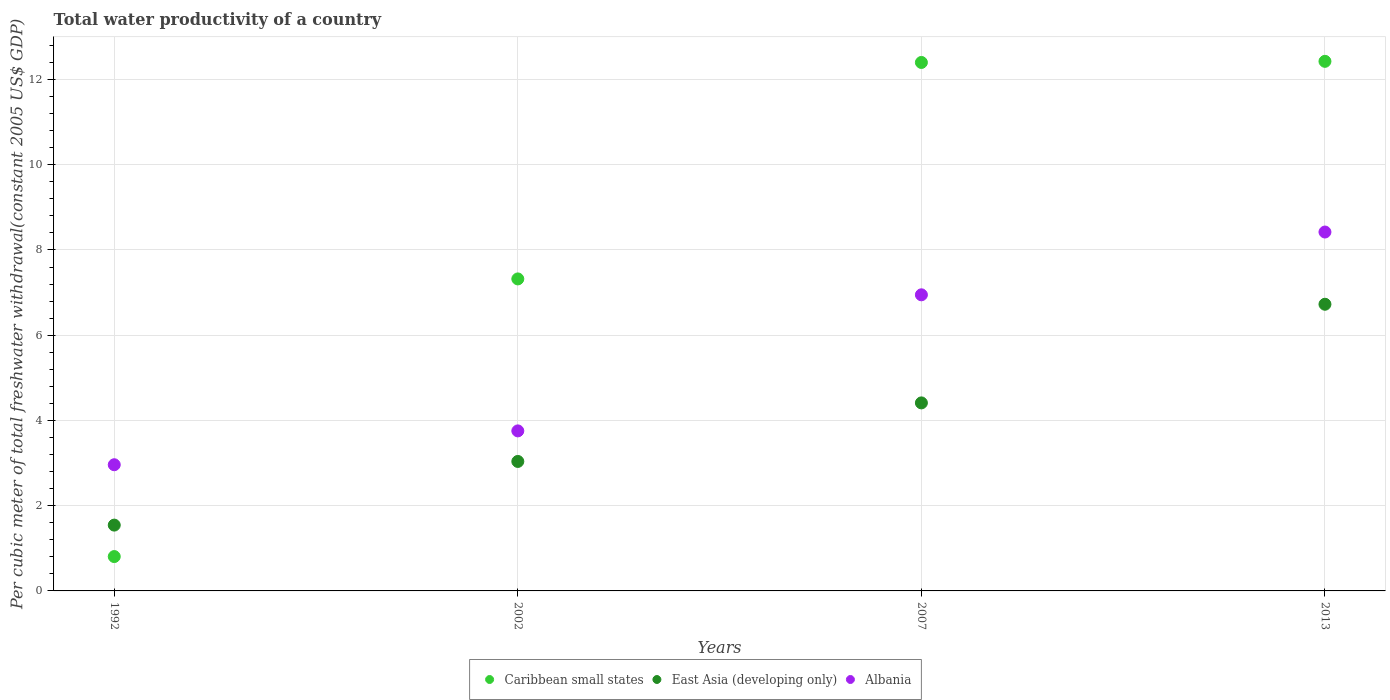How many different coloured dotlines are there?
Your answer should be compact. 3. What is the total water productivity in Albania in 2007?
Ensure brevity in your answer.  6.95. Across all years, what is the maximum total water productivity in Caribbean small states?
Give a very brief answer. 12.43. Across all years, what is the minimum total water productivity in Albania?
Your answer should be compact. 2.96. What is the total total water productivity in Albania in the graph?
Provide a succinct answer. 22.09. What is the difference between the total water productivity in Caribbean small states in 1992 and that in 2013?
Keep it short and to the point. -11.62. What is the difference between the total water productivity in Caribbean small states in 2002 and the total water productivity in Albania in 1992?
Give a very brief answer. 4.36. What is the average total water productivity in East Asia (developing only) per year?
Provide a short and direct response. 3.93. In the year 1992, what is the difference between the total water productivity in Albania and total water productivity in East Asia (developing only)?
Offer a terse response. 1.42. What is the ratio of the total water productivity in Caribbean small states in 1992 to that in 2002?
Provide a succinct answer. 0.11. Is the total water productivity in Albania in 1992 less than that in 2002?
Give a very brief answer. Yes. What is the difference between the highest and the second highest total water productivity in Albania?
Your answer should be compact. 1.47. What is the difference between the highest and the lowest total water productivity in East Asia (developing only)?
Your answer should be very brief. 5.18. Is the total water productivity in Albania strictly greater than the total water productivity in East Asia (developing only) over the years?
Your answer should be compact. Yes. How many years are there in the graph?
Keep it short and to the point. 4. What is the difference between two consecutive major ticks on the Y-axis?
Provide a short and direct response. 2. Does the graph contain grids?
Make the answer very short. Yes. How many legend labels are there?
Keep it short and to the point. 3. How are the legend labels stacked?
Provide a short and direct response. Horizontal. What is the title of the graph?
Ensure brevity in your answer.  Total water productivity of a country. Does "Tunisia" appear as one of the legend labels in the graph?
Give a very brief answer. No. What is the label or title of the X-axis?
Your answer should be compact. Years. What is the label or title of the Y-axis?
Provide a succinct answer. Per cubic meter of total freshwater withdrawal(constant 2005 US$ GDP). What is the Per cubic meter of total freshwater withdrawal(constant 2005 US$ GDP) of Caribbean small states in 1992?
Offer a terse response. 0.81. What is the Per cubic meter of total freshwater withdrawal(constant 2005 US$ GDP) in East Asia (developing only) in 1992?
Provide a succinct answer. 1.54. What is the Per cubic meter of total freshwater withdrawal(constant 2005 US$ GDP) in Albania in 1992?
Offer a very short reply. 2.96. What is the Per cubic meter of total freshwater withdrawal(constant 2005 US$ GDP) in Caribbean small states in 2002?
Give a very brief answer. 7.32. What is the Per cubic meter of total freshwater withdrawal(constant 2005 US$ GDP) of East Asia (developing only) in 2002?
Make the answer very short. 3.04. What is the Per cubic meter of total freshwater withdrawal(constant 2005 US$ GDP) in Albania in 2002?
Offer a terse response. 3.76. What is the Per cubic meter of total freshwater withdrawal(constant 2005 US$ GDP) in Caribbean small states in 2007?
Provide a short and direct response. 12.4. What is the Per cubic meter of total freshwater withdrawal(constant 2005 US$ GDP) in East Asia (developing only) in 2007?
Ensure brevity in your answer.  4.41. What is the Per cubic meter of total freshwater withdrawal(constant 2005 US$ GDP) in Albania in 2007?
Keep it short and to the point. 6.95. What is the Per cubic meter of total freshwater withdrawal(constant 2005 US$ GDP) of Caribbean small states in 2013?
Make the answer very short. 12.43. What is the Per cubic meter of total freshwater withdrawal(constant 2005 US$ GDP) in East Asia (developing only) in 2013?
Provide a succinct answer. 6.73. What is the Per cubic meter of total freshwater withdrawal(constant 2005 US$ GDP) in Albania in 2013?
Ensure brevity in your answer.  8.42. Across all years, what is the maximum Per cubic meter of total freshwater withdrawal(constant 2005 US$ GDP) in Caribbean small states?
Offer a terse response. 12.43. Across all years, what is the maximum Per cubic meter of total freshwater withdrawal(constant 2005 US$ GDP) of East Asia (developing only)?
Keep it short and to the point. 6.73. Across all years, what is the maximum Per cubic meter of total freshwater withdrawal(constant 2005 US$ GDP) of Albania?
Make the answer very short. 8.42. Across all years, what is the minimum Per cubic meter of total freshwater withdrawal(constant 2005 US$ GDP) in Caribbean small states?
Offer a very short reply. 0.81. Across all years, what is the minimum Per cubic meter of total freshwater withdrawal(constant 2005 US$ GDP) of East Asia (developing only)?
Offer a very short reply. 1.54. Across all years, what is the minimum Per cubic meter of total freshwater withdrawal(constant 2005 US$ GDP) of Albania?
Make the answer very short. 2.96. What is the total Per cubic meter of total freshwater withdrawal(constant 2005 US$ GDP) in Caribbean small states in the graph?
Make the answer very short. 32.95. What is the total Per cubic meter of total freshwater withdrawal(constant 2005 US$ GDP) of East Asia (developing only) in the graph?
Offer a very short reply. 15.72. What is the total Per cubic meter of total freshwater withdrawal(constant 2005 US$ GDP) of Albania in the graph?
Your answer should be compact. 22.09. What is the difference between the Per cubic meter of total freshwater withdrawal(constant 2005 US$ GDP) of Caribbean small states in 1992 and that in 2002?
Your response must be concise. -6.51. What is the difference between the Per cubic meter of total freshwater withdrawal(constant 2005 US$ GDP) in East Asia (developing only) in 1992 and that in 2002?
Keep it short and to the point. -1.49. What is the difference between the Per cubic meter of total freshwater withdrawal(constant 2005 US$ GDP) in Albania in 1992 and that in 2002?
Give a very brief answer. -0.79. What is the difference between the Per cubic meter of total freshwater withdrawal(constant 2005 US$ GDP) of Caribbean small states in 1992 and that in 2007?
Provide a short and direct response. -11.59. What is the difference between the Per cubic meter of total freshwater withdrawal(constant 2005 US$ GDP) in East Asia (developing only) in 1992 and that in 2007?
Offer a very short reply. -2.87. What is the difference between the Per cubic meter of total freshwater withdrawal(constant 2005 US$ GDP) of Albania in 1992 and that in 2007?
Your answer should be very brief. -3.99. What is the difference between the Per cubic meter of total freshwater withdrawal(constant 2005 US$ GDP) of Caribbean small states in 1992 and that in 2013?
Provide a succinct answer. -11.62. What is the difference between the Per cubic meter of total freshwater withdrawal(constant 2005 US$ GDP) in East Asia (developing only) in 1992 and that in 2013?
Provide a short and direct response. -5.18. What is the difference between the Per cubic meter of total freshwater withdrawal(constant 2005 US$ GDP) of Albania in 1992 and that in 2013?
Provide a short and direct response. -5.46. What is the difference between the Per cubic meter of total freshwater withdrawal(constant 2005 US$ GDP) of Caribbean small states in 2002 and that in 2007?
Your response must be concise. -5.08. What is the difference between the Per cubic meter of total freshwater withdrawal(constant 2005 US$ GDP) in East Asia (developing only) in 2002 and that in 2007?
Your response must be concise. -1.37. What is the difference between the Per cubic meter of total freshwater withdrawal(constant 2005 US$ GDP) of Albania in 2002 and that in 2007?
Your answer should be very brief. -3.19. What is the difference between the Per cubic meter of total freshwater withdrawal(constant 2005 US$ GDP) of Caribbean small states in 2002 and that in 2013?
Provide a short and direct response. -5.11. What is the difference between the Per cubic meter of total freshwater withdrawal(constant 2005 US$ GDP) in East Asia (developing only) in 2002 and that in 2013?
Make the answer very short. -3.69. What is the difference between the Per cubic meter of total freshwater withdrawal(constant 2005 US$ GDP) in Albania in 2002 and that in 2013?
Give a very brief answer. -4.67. What is the difference between the Per cubic meter of total freshwater withdrawal(constant 2005 US$ GDP) of Caribbean small states in 2007 and that in 2013?
Your answer should be compact. -0.03. What is the difference between the Per cubic meter of total freshwater withdrawal(constant 2005 US$ GDP) in East Asia (developing only) in 2007 and that in 2013?
Your answer should be compact. -2.31. What is the difference between the Per cubic meter of total freshwater withdrawal(constant 2005 US$ GDP) in Albania in 2007 and that in 2013?
Your answer should be compact. -1.47. What is the difference between the Per cubic meter of total freshwater withdrawal(constant 2005 US$ GDP) in Caribbean small states in 1992 and the Per cubic meter of total freshwater withdrawal(constant 2005 US$ GDP) in East Asia (developing only) in 2002?
Provide a succinct answer. -2.23. What is the difference between the Per cubic meter of total freshwater withdrawal(constant 2005 US$ GDP) of Caribbean small states in 1992 and the Per cubic meter of total freshwater withdrawal(constant 2005 US$ GDP) of Albania in 2002?
Make the answer very short. -2.95. What is the difference between the Per cubic meter of total freshwater withdrawal(constant 2005 US$ GDP) in East Asia (developing only) in 1992 and the Per cubic meter of total freshwater withdrawal(constant 2005 US$ GDP) in Albania in 2002?
Give a very brief answer. -2.21. What is the difference between the Per cubic meter of total freshwater withdrawal(constant 2005 US$ GDP) of Caribbean small states in 1992 and the Per cubic meter of total freshwater withdrawal(constant 2005 US$ GDP) of East Asia (developing only) in 2007?
Offer a very short reply. -3.61. What is the difference between the Per cubic meter of total freshwater withdrawal(constant 2005 US$ GDP) in Caribbean small states in 1992 and the Per cubic meter of total freshwater withdrawal(constant 2005 US$ GDP) in Albania in 2007?
Ensure brevity in your answer.  -6.14. What is the difference between the Per cubic meter of total freshwater withdrawal(constant 2005 US$ GDP) in East Asia (developing only) in 1992 and the Per cubic meter of total freshwater withdrawal(constant 2005 US$ GDP) in Albania in 2007?
Offer a terse response. -5.4. What is the difference between the Per cubic meter of total freshwater withdrawal(constant 2005 US$ GDP) of Caribbean small states in 1992 and the Per cubic meter of total freshwater withdrawal(constant 2005 US$ GDP) of East Asia (developing only) in 2013?
Provide a short and direct response. -5.92. What is the difference between the Per cubic meter of total freshwater withdrawal(constant 2005 US$ GDP) of Caribbean small states in 1992 and the Per cubic meter of total freshwater withdrawal(constant 2005 US$ GDP) of Albania in 2013?
Provide a succinct answer. -7.62. What is the difference between the Per cubic meter of total freshwater withdrawal(constant 2005 US$ GDP) in East Asia (developing only) in 1992 and the Per cubic meter of total freshwater withdrawal(constant 2005 US$ GDP) in Albania in 2013?
Your response must be concise. -6.88. What is the difference between the Per cubic meter of total freshwater withdrawal(constant 2005 US$ GDP) in Caribbean small states in 2002 and the Per cubic meter of total freshwater withdrawal(constant 2005 US$ GDP) in East Asia (developing only) in 2007?
Ensure brevity in your answer.  2.91. What is the difference between the Per cubic meter of total freshwater withdrawal(constant 2005 US$ GDP) of Caribbean small states in 2002 and the Per cubic meter of total freshwater withdrawal(constant 2005 US$ GDP) of Albania in 2007?
Offer a terse response. 0.37. What is the difference between the Per cubic meter of total freshwater withdrawal(constant 2005 US$ GDP) in East Asia (developing only) in 2002 and the Per cubic meter of total freshwater withdrawal(constant 2005 US$ GDP) in Albania in 2007?
Give a very brief answer. -3.91. What is the difference between the Per cubic meter of total freshwater withdrawal(constant 2005 US$ GDP) of Caribbean small states in 2002 and the Per cubic meter of total freshwater withdrawal(constant 2005 US$ GDP) of East Asia (developing only) in 2013?
Offer a very short reply. 0.59. What is the difference between the Per cubic meter of total freshwater withdrawal(constant 2005 US$ GDP) of Caribbean small states in 2002 and the Per cubic meter of total freshwater withdrawal(constant 2005 US$ GDP) of Albania in 2013?
Make the answer very short. -1.1. What is the difference between the Per cubic meter of total freshwater withdrawal(constant 2005 US$ GDP) in East Asia (developing only) in 2002 and the Per cubic meter of total freshwater withdrawal(constant 2005 US$ GDP) in Albania in 2013?
Offer a very short reply. -5.38. What is the difference between the Per cubic meter of total freshwater withdrawal(constant 2005 US$ GDP) of Caribbean small states in 2007 and the Per cubic meter of total freshwater withdrawal(constant 2005 US$ GDP) of East Asia (developing only) in 2013?
Your response must be concise. 5.67. What is the difference between the Per cubic meter of total freshwater withdrawal(constant 2005 US$ GDP) in Caribbean small states in 2007 and the Per cubic meter of total freshwater withdrawal(constant 2005 US$ GDP) in Albania in 2013?
Your answer should be compact. 3.98. What is the difference between the Per cubic meter of total freshwater withdrawal(constant 2005 US$ GDP) in East Asia (developing only) in 2007 and the Per cubic meter of total freshwater withdrawal(constant 2005 US$ GDP) in Albania in 2013?
Give a very brief answer. -4.01. What is the average Per cubic meter of total freshwater withdrawal(constant 2005 US$ GDP) in Caribbean small states per year?
Give a very brief answer. 8.24. What is the average Per cubic meter of total freshwater withdrawal(constant 2005 US$ GDP) in East Asia (developing only) per year?
Your answer should be very brief. 3.93. What is the average Per cubic meter of total freshwater withdrawal(constant 2005 US$ GDP) of Albania per year?
Keep it short and to the point. 5.52. In the year 1992, what is the difference between the Per cubic meter of total freshwater withdrawal(constant 2005 US$ GDP) of Caribbean small states and Per cubic meter of total freshwater withdrawal(constant 2005 US$ GDP) of East Asia (developing only)?
Ensure brevity in your answer.  -0.74. In the year 1992, what is the difference between the Per cubic meter of total freshwater withdrawal(constant 2005 US$ GDP) in Caribbean small states and Per cubic meter of total freshwater withdrawal(constant 2005 US$ GDP) in Albania?
Give a very brief answer. -2.15. In the year 1992, what is the difference between the Per cubic meter of total freshwater withdrawal(constant 2005 US$ GDP) in East Asia (developing only) and Per cubic meter of total freshwater withdrawal(constant 2005 US$ GDP) in Albania?
Your response must be concise. -1.42. In the year 2002, what is the difference between the Per cubic meter of total freshwater withdrawal(constant 2005 US$ GDP) in Caribbean small states and Per cubic meter of total freshwater withdrawal(constant 2005 US$ GDP) in East Asia (developing only)?
Your response must be concise. 4.28. In the year 2002, what is the difference between the Per cubic meter of total freshwater withdrawal(constant 2005 US$ GDP) of Caribbean small states and Per cubic meter of total freshwater withdrawal(constant 2005 US$ GDP) of Albania?
Provide a short and direct response. 3.57. In the year 2002, what is the difference between the Per cubic meter of total freshwater withdrawal(constant 2005 US$ GDP) of East Asia (developing only) and Per cubic meter of total freshwater withdrawal(constant 2005 US$ GDP) of Albania?
Keep it short and to the point. -0.72. In the year 2007, what is the difference between the Per cubic meter of total freshwater withdrawal(constant 2005 US$ GDP) of Caribbean small states and Per cubic meter of total freshwater withdrawal(constant 2005 US$ GDP) of East Asia (developing only)?
Give a very brief answer. 7.99. In the year 2007, what is the difference between the Per cubic meter of total freshwater withdrawal(constant 2005 US$ GDP) of Caribbean small states and Per cubic meter of total freshwater withdrawal(constant 2005 US$ GDP) of Albania?
Provide a succinct answer. 5.45. In the year 2007, what is the difference between the Per cubic meter of total freshwater withdrawal(constant 2005 US$ GDP) of East Asia (developing only) and Per cubic meter of total freshwater withdrawal(constant 2005 US$ GDP) of Albania?
Give a very brief answer. -2.54. In the year 2013, what is the difference between the Per cubic meter of total freshwater withdrawal(constant 2005 US$ GDP) of Caribbean small states and Per cubic meter of total freshwater withdrawal(constant 2005 US$ GDP) of East Asia (developing only)?
Make the answer very short. 5.7. In the year 2013, what is the difference between the Per cubic meter of total freshwater withdrawal(constant 2005 US$ GDP) of Caribbean small states and Per cubic meter of total freshwater withdrawal(constant 2005 US$ GDP) of Albania?
Your answer should be compact. 4.01. In the year 2013, what is the difference between the Per cubic meter of total freshwater withdrawal(constant 2005 US$ GDP) in East Asia (developing only) and Per cubic meter of total freshwater withdrawal(constant 2005 US$ GDP) in Albania?
Give a very brief answer. -1.69. What is the ratio of the Per cubic meter of total freshwater withdrawal(constant 2005 US$ GDP) of Caribbean small states in 1992 to that in 2002?
Provide a succinct answer. 0.11. What is the ratio of the Per cubic meter of total freshwater withdrawal(constant 2005 US$ GDP) of East Asia (developing only) in 1992 to that in 2002?
Offer a very short reply. 0.51. What is the ratio of the Per cubic meter of total freshwater withdrawal(constant 2005 US$ GDP) in Albania in 1992 to that in 2002?
Your response must be concise. 0.79. What is the ratio of the Per cubic meter of total freshwater withdrawal(constant 2005 US$ GDP) in Caribbean small states in 1992 to that in 2007?
Provide a short and direct response. 0.07. What is the ratio of the Per cubic meter of total freshwater withdrawal(constant 2005 US$ GDP) in Albania in 1992 to that in 2007?
Make the answer very short. 0.43. What is the ratio of the Per cubic meter of total freshwater withdrawal(constant 2005 US$ GDP) in Caribbean small states in 1992 to that in 2013?
Provide a succinct answer. 0.06. What is the ratio of the Per cubic meter of total freshwater withdrawal(constant 2005 US$ GDP) in East Asia (developing only) in 1992 to that in 2013?
Keep it short and to the point. 0.23. What is the ratio of the Per cubic meter of total freshwater withdrawal(constant 2005 US$ GDP) of Albania in 1992 to that in 2013?
Keep it short and to the point. 0.35. What is the ratio of the Per cubic meter of total freshwater withdrawal(constant 2005 US$ GDP) of Caribbean small states in 2002 to that in 2007?
Provide a short and direct response. 0.59. What is the ratio of the Per cubic meter of total freshwater withdrawal(constant 2005 US$ GDP) in East Asia (developing only) in 2002 to that in 2007?
Make the answer very short. 0.69. What is the ratio of the Per cubic meter of total freshwater withdrawal(constant 2005 US$ GDP) of Albania in 2002 to that in 2007?
Your answer should be very brief. 0.54. What is the ratio of the Per cubic meter of total freshwater withdrawal(constant 2005 US$ GDP) in Caribbean small states in 2002 to that in 2013?
Provide a short and direct response. 0.59. What is the ratio of the Per cubic meter of total freshwater withdrawal(constant 2005 US$ GDP) of East Asia (developing only) in 2002 to that in 2013?
Offer a terse response. 0.45. What is the ratio of the Per cubic meter of total freshwater withdrawal(constant 2005 US$ GDP) in Albania in 2002 to that in 2013?
Keep it short and to the point. 0.45. What is the ratio of the Per cubic meter of total freshwater withdrawal(constant 2005 US$ GDP) in East Asia (developing only) in 2007 to that in 2013?
Make the answer very short. 0.66. What is the ratio of the Per cubic meter of total freshwater withdrawal(constant 2005 US$ GDP) of Albania in 2007 to that in 2013?
Make the answer very short. 0.83. What is the difference between the highest and the second highest Per cubic meter of total freshwater withdrawal(constant 2005 US$ GDP) in Caribbean small states?
Keep it short and to the point. 0.03. What is the difference between the highest and the second highest Per cubic meter of total freshwater withdrawal(constant 2005 US$ GDP) in East Asia (developing only)?
Give a very brief answer. 2.31. What is the difference between the highest and the second highest Per cubic meter of total freshwater withdrawal(constant 2005 US$ GDP) of Albania?
Your response must be concise. 1.47. What is the difference between the highest and the lowest Per cubic meter of total freshwater withdrawal(constant 2005 US$ GDP) in Caribbean small states?
Keep it short and to the point. 11.62. What is the difference between the highest and the lowest Per cubic meter of total freshwater withdrawal(constant 2005 US$ GDP) of East Asia (developing only)?
Ensure brevity in your answer.  5.18. What is the difference between the highest and the lowest Per cubic meter of total freshwater withdrawal(constant 2005 US$ GDP) in Albania?
Provide a succinct answer. 5.46. 